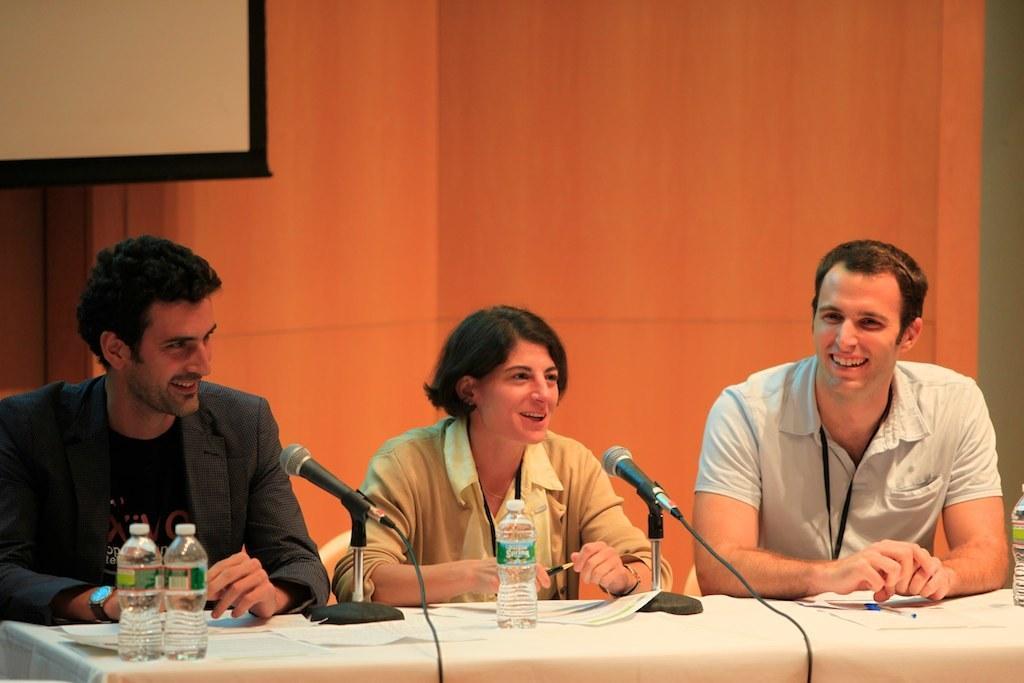How would you summarize this image in a sentence or two? In this picture there are three people sitting in front of a table, having a microphones on it. There are some water bottles and papers on the table. In the background there is a projector screen display and wall here. 